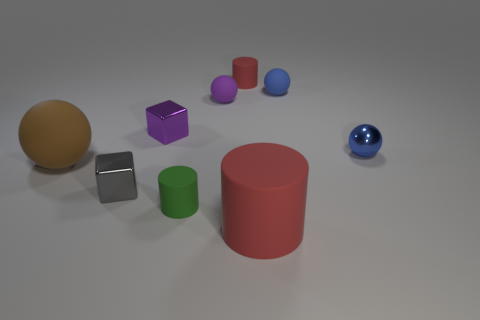Subtract all large red cylinders. How many cylinders are left? 2 Subtract all red balls. How many red cylinders are left? 2 Add 1 small purple rubber spheres. How many objects exist? 10 Subtract all brown balls. How many balls are left? 3 Subtract 2 spheres. How many spheres are left? 2 Subtract all red balls. Subtract all cyan cylinders. How many balls are left? 4 Subtract all cylinders. How many objects are left? 6 Subtract all brown matte objects. Subtract all tiny blue rubber objects. How many objects are left? 7 Add 6 green objects. How many green objects are left? 7 Add 2 big blue blocks. How many big blue blocks exist? 2 